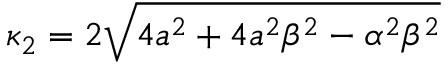Convert formula to latex. <formula><loc_0><loc_0><loc_500><loc_500>\kappa _ { 2 } = 2 \sqrt { 4 a ^ { 2 } + 4 a ^ { 2 } \beta ^ { 2 } - \alpha ^ { 2 } \beta ^ { 2 } }</formula> 